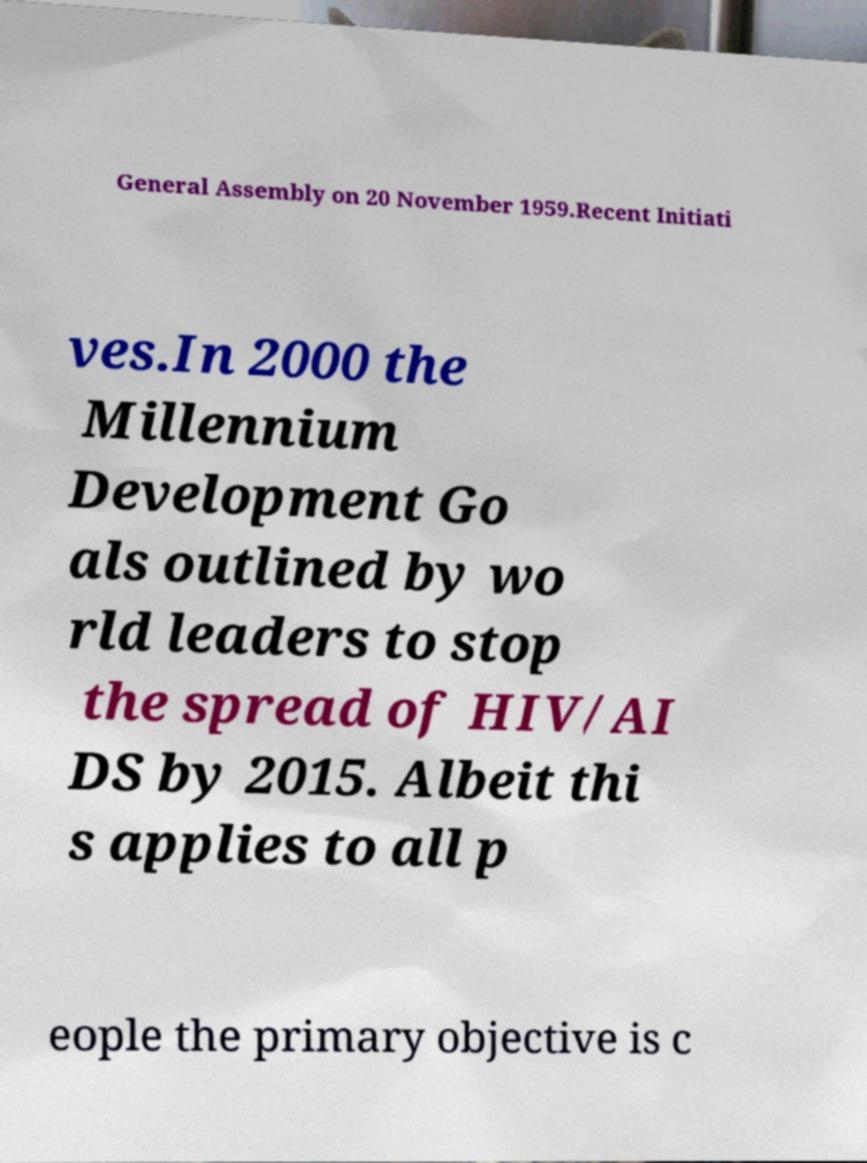Can you read and provide the text displayed in the image?This photo seems to have some interesting text. Can you extract and type it out for me? General Assembly on 20 November 1959.Recent Initiati ves.In 2000 the Millennium Development Go als outlined by wo rld leaders to stop the spread of HIV/AI DS by 2015. Albeit thi s applies to all p eople the primary objective is c 